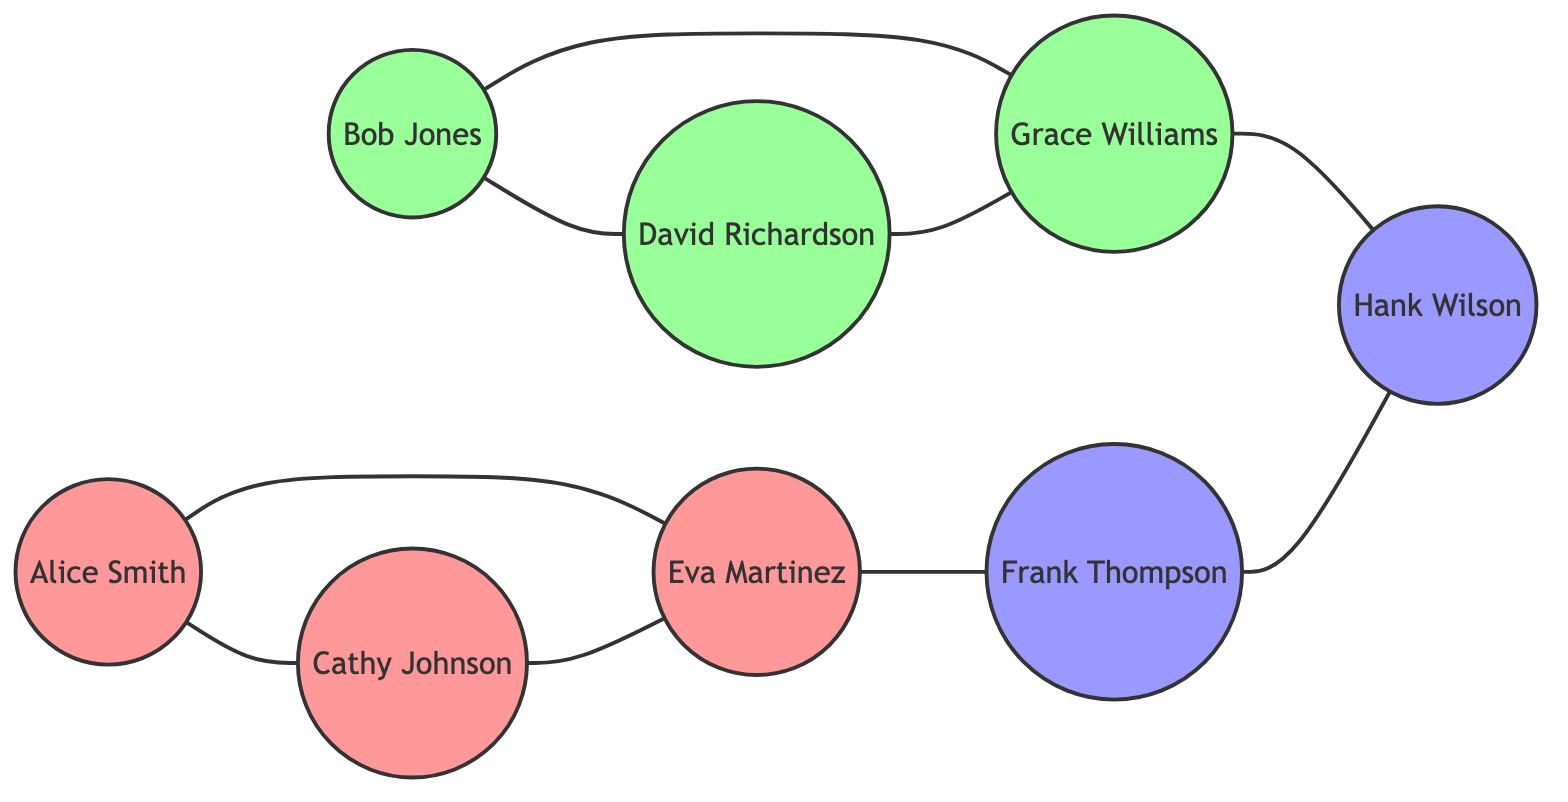What is the total number of nodes in the graph? The graph contains eight distinct individuals represented as nodes: Alice Smith, Bob Jones, Cathy Johnson, David Richardson, Eva Martinez, Frank Thompson, Grace Williams, and Hank Wilson. Therefore, the total number of nodes is eight.
Answer: 8 How many friends does Eva Martinez have? Eva Martinez is connected to three distinct individuals in the graph: Alice Smith, Cathy Johnson, and Frank Thompson. Thus, Eva Martinez has three friends.
Answer: 3 Who are the friends of Grace Williams? Grace Williams is linked to two individuals: Bob Jones and Hank Wilson. Therefore, the friends of Grace Williams are Bob Jones and Hank Wilson.
Answer: Bob Jones, Hank Wilson Which class has the most individuals represented in the graph? There are three individuals from the Class of 2015 (Alice Smith, Cathy Johnson, and Eva Martinez) and two from the Class of 2016 (Bob Jones and David Richardson), along with two from the Class of 2017 (Frank Thompson and Hank Wilson). Since the Class of 2015 has the highest count of three individuals, it has the most representation.
Answer: Class of 2015 Is there a direct friendship between David Richardson and Cathy Johnson? The links in the graph indicate that David Richardson is connected to Grace Williams, while Cathy Johnson is linked to Alice Smith, Eva Martinez, and each other but not to David Richardson. Thus, there is no direct friendship between David Richardson and Cathy Johnson.
Answer: No What is the total number of friendships (links) represented in the graph? By counting the links directly from the provided data, there are nine connections shown: Alice Smith to Cathy Johnson, Alice Smith to Eva Martinez, Bob Jones to David Richardson, Bob Jones to Grace Williams, Cathy Johnson to Eva Martinez, David Richardson to Grace Williams, Eva Martinez to Frank Thompson, Grace Williams to Hank Wilson, and Frank Thompson to Hank Wilson. Thus, there are nine friendships in total.
Answer: 9 Which two individuals are friends with both Bob Jones and Grace Williams? Bob Jones is friends with David Richardson and Grace Williams, while Grace Williams is friends with Bob Jones, David Richardson, and Hank Wilson. The connecting link is through David Richardson, who connects both friend groups. Hence, David Richardson is the only individual who is a mutual friend of both Bob Jones and Grace Williams.
Answer: David Richardson Which node represents the individual from Class of 2017 that has the most friends? Frank Thompson and Hank Wilson both belong to the Class of 2017; Frank Thompson is friends with Eva Martinez and Hank Wilson while Hank Wilson is friends with Grace Williams and Frank Thompson. Since both Frank and Hank have two friends each, but they are linked with each other, it can be determined that Frank Thompson is the best representative for Class of 2017 due to direct friendship links with one more individual.
Answer: Frank Thompson 